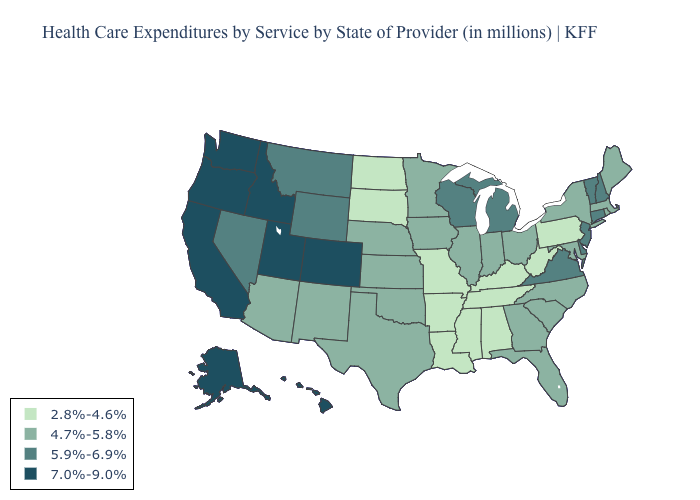Name the states that have a value in the range 7.0%-9.0%?
Concise answer only. Alaska, California, Colorado, Hawaii, Idaho, Oregon, Utah, Washington. What is the value of Pennsylvania?
Keep it brief. 2.8%-4.6%. What is the highest value in the Northeast ?
Keep it brief. 5.9%-6.9%. Does the map have missing data?
Quick response, please. No. Does Idaho have a higher value than Hawaii?
Keep it brief. No. Does Maine have the lowest value in the USA?
Give a very brief answer. No. What is the value of Virginia?
Answer briefly. 5.9%-6.9%. Does New Hampshire have the same value as Wisconsin?
Quick response, please. Yes. Name the states that have a value in the range 4.7%-5.8%?
Give a very brief answer. Arizona, Florida, Georgia, Illinois, Indiana, Iowa, Kansas, Maine, Maryland, Massachusetts, Minnesota, Nebraska, New Mexico, New York, North Carolina, Ohio, Oklahoma, Rhode Island, South Carolina, Texas. Name the states that have a value in the range 5.9%-6.9%?
Write a very short answer. Connecticut, Delaware, Michigan, Montana, Nevada, New Hampshire, New Jersey, Vermont, Virginia, Wisconsin, Wyoming. Which states have the lowest value in the USA?
Be succinct. Alabama, Arkansas, Kentucky, Louisiana, Mississippi, Missouri, North Dakota, Pennsylvania, South Dakota, Tennessee, West Virginia. What is the highest value in states that border Missouri?
Keep it brief. 4.7%-5.8%. Does the map have missing data?
Quick response, please. No. Does California have the same value as Washington?
Give a very brief answer. Yes. Does Indiana have the same value as New Jersey?
Give a very brief answer. No. 